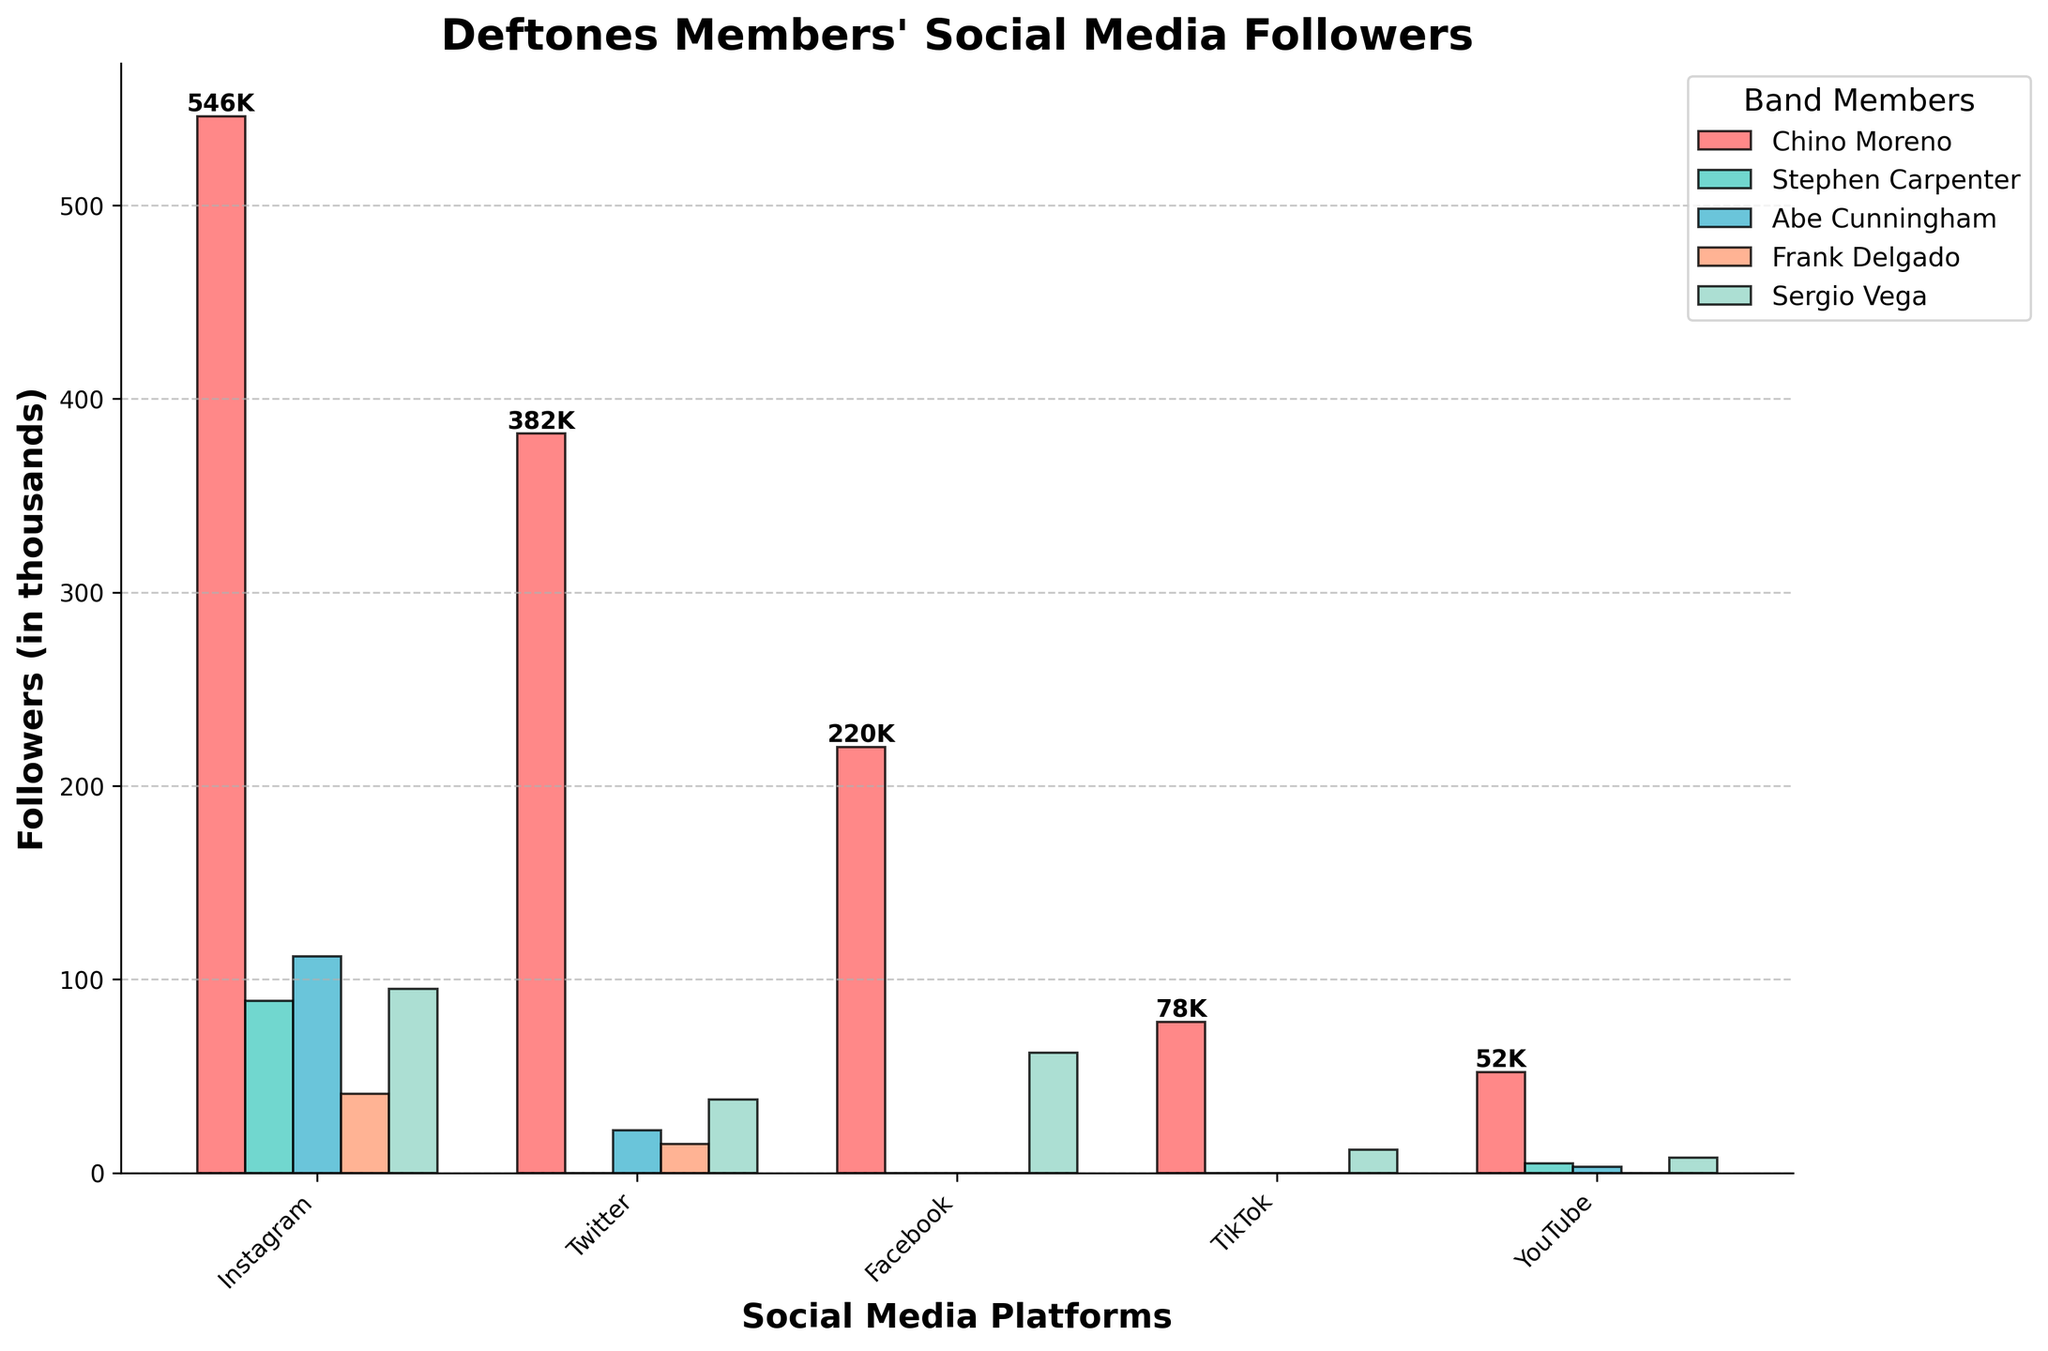What's the total number of followers for Chino Moreno across all platforms? Add Chino's followers on Instagram (546,000), Twitter (382,000), Facebook (220,000), TikTok (78,000), and YouTube (52,000). The total is 546,000 + 382,000 + 220,000 + 78,000 + 52,000 = 1,278,000.
Answer: 1,278,000 Which band member has the least followers on Instagram? Check the Instagram followers for each band member: Chino Moreno (546,000), Stephen Carpenter (89,000), Abe Cunningham (112,000), Frank Delgado (41,000), Sergio Vega (95,000). Frank Delgado has the fewest.
Answer: Frank Delgado On which platform does Chino Moreno have the greatest number of followers? Compare Chino's followers on each platform: Instagram (546,000), Twitter (382,000), Facebook (220,000), TikTok (78,000), YouTube (52,000). Instagram has the highest number.
Answer: Instagram What's the average number of followers Abe Cunningham has on the platforms he is active on? Abe Cunningham is active on Instagram (112,000), Twitter (22,000), and YouTube (3,000). The average is (112,000 + 22,000 + 3,000) / 3 = 45,666.67.
Answer: 45,666.67 Who has more followers on TikTok, Chino Moreno or Sergio Vega? Compare Chino's TikTok followers (78,000) with Sergio Vega's (12,000). Chino Moreno has more.
Answer: Chino Moreno List the platforms on which Stephen Carpenter is not active. Stephen Carpenter is active on Instagram (89,000) and YouTube (5,000). He is not active on Twitter, Facebook, and TikTok.
Answer: Twitter, Facebook, TikTok Is Frank Delgado active on more platforms than Sergio Vega? Frank Delgado is active on Instagram (41,000) and Twitter (15,000), so he is active on 2 platforms. Sergio Vega is active on Instagram (95,000), Twitter (38,000), Facebook (62,000), TikTok (12,000), and YouTube (8,000), so he is active on 5 platforms. Sergio Vega is active on more platforms.
Answer: No What is the total number of followers all band members have on YouTube? Sum the YouTube followers for each band member: Chino Moreno (52,000), Stephen Carpenter (5,000), Abe Cunningham (3,000), Frank Delgado (0), Sergio Vega (8,000). The total is 52,000 + 5,000 + 3,000 + 0 + 8,000 = 68,000.
Answer: 68,000 Which band member has the largest difference in followers between the platform where they are most and least followed? Calculate the difference for each member:
Chino Moreno: Instagram (546,000) - YouTube (52,000) = 494,000
Stephen Carpenter: Instagram (89,000) - YouTube (5,000) = 84,000
Abe Cunningham: Instagram (112,000) - YouTube (3,000) = 109,000
Frank Delgado: Instagram (41,000) - Twitter (15,000) = 26,000
Sergio Vega: Instagram (95,000) - TikTok (12,000) = 83,000 
Chino Moreno has the largest difference.
Answer: Chino Moreno How many total followers do Abe Cunningham and Sergio Vega have on Instagram combined? Sum Abe Cunningham's Instagram followers (112,000) and Sergio Vega's Instagram followers (95,000). The total is 112,000 + 95,000 = 207,000.
Answer: 207,000 